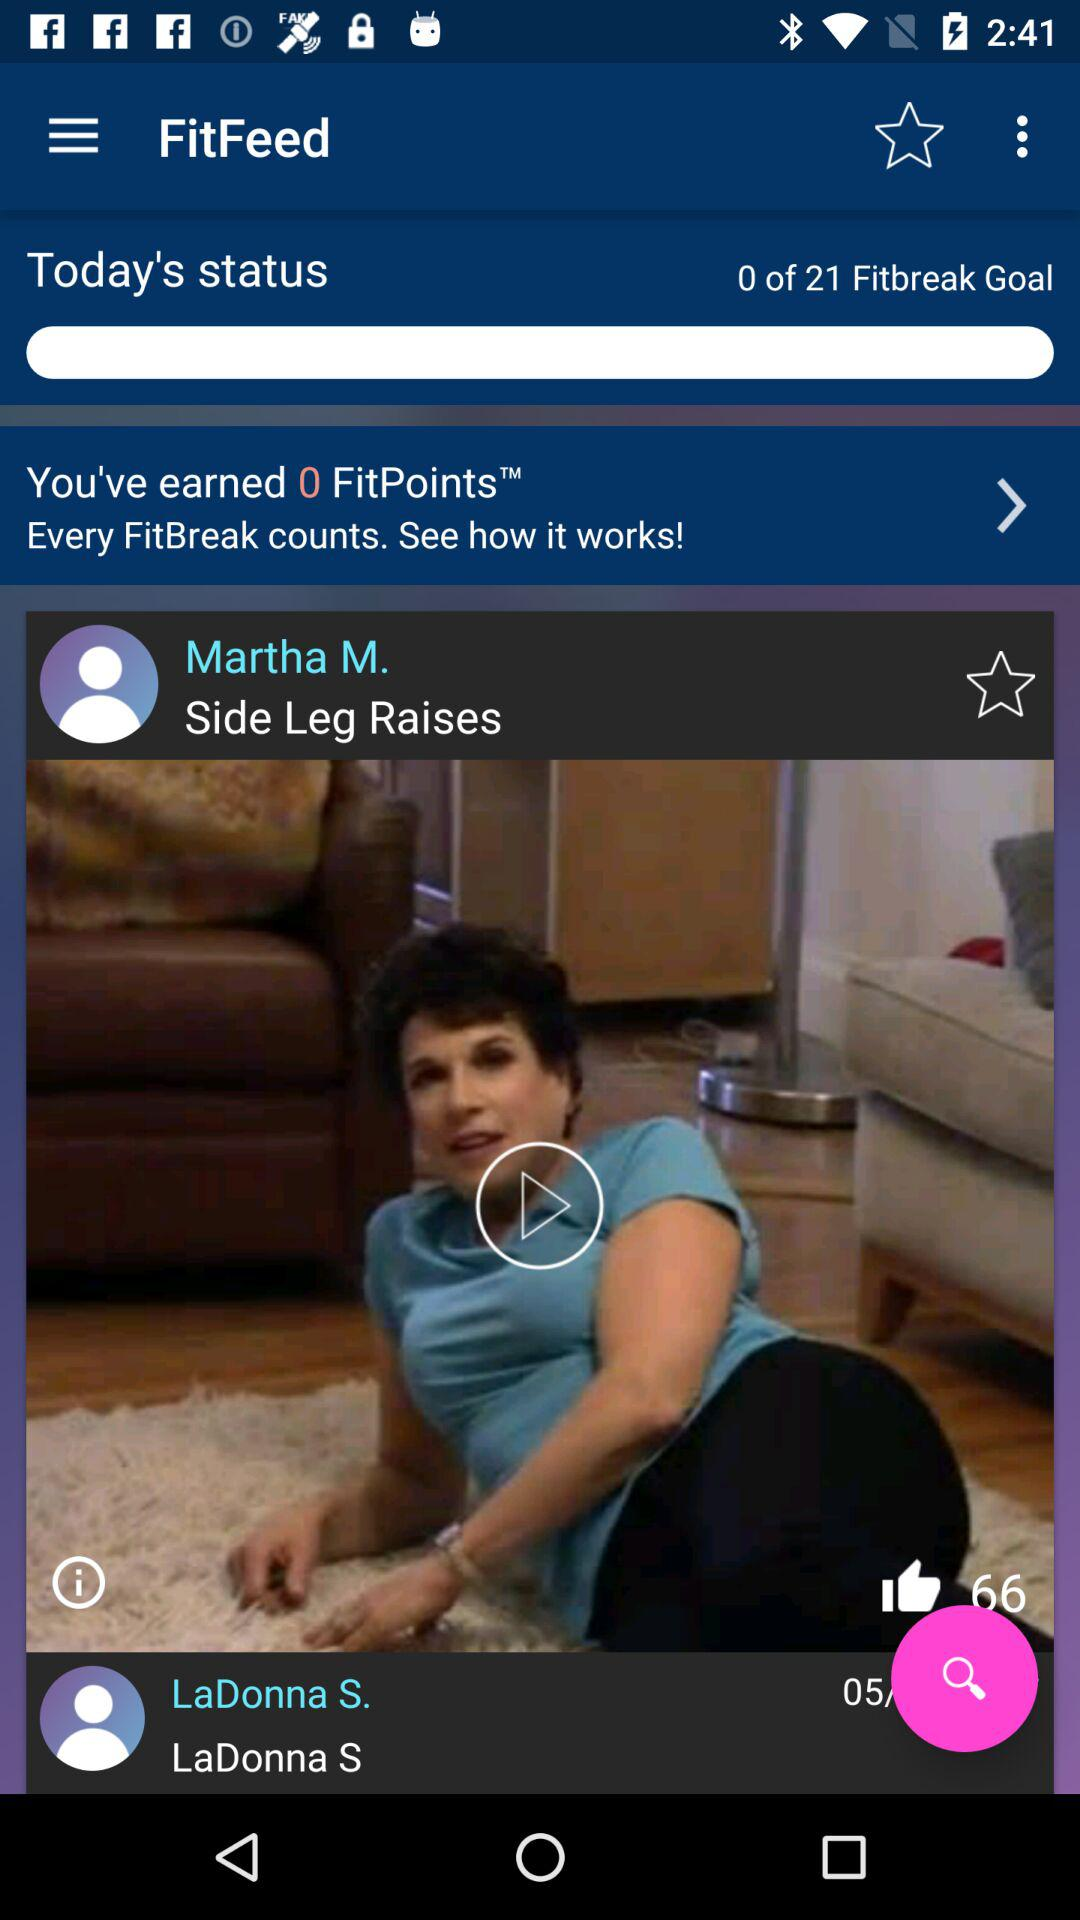What are the mentioned user names? The mentioned user names are Martha M. and LaDonna S. 